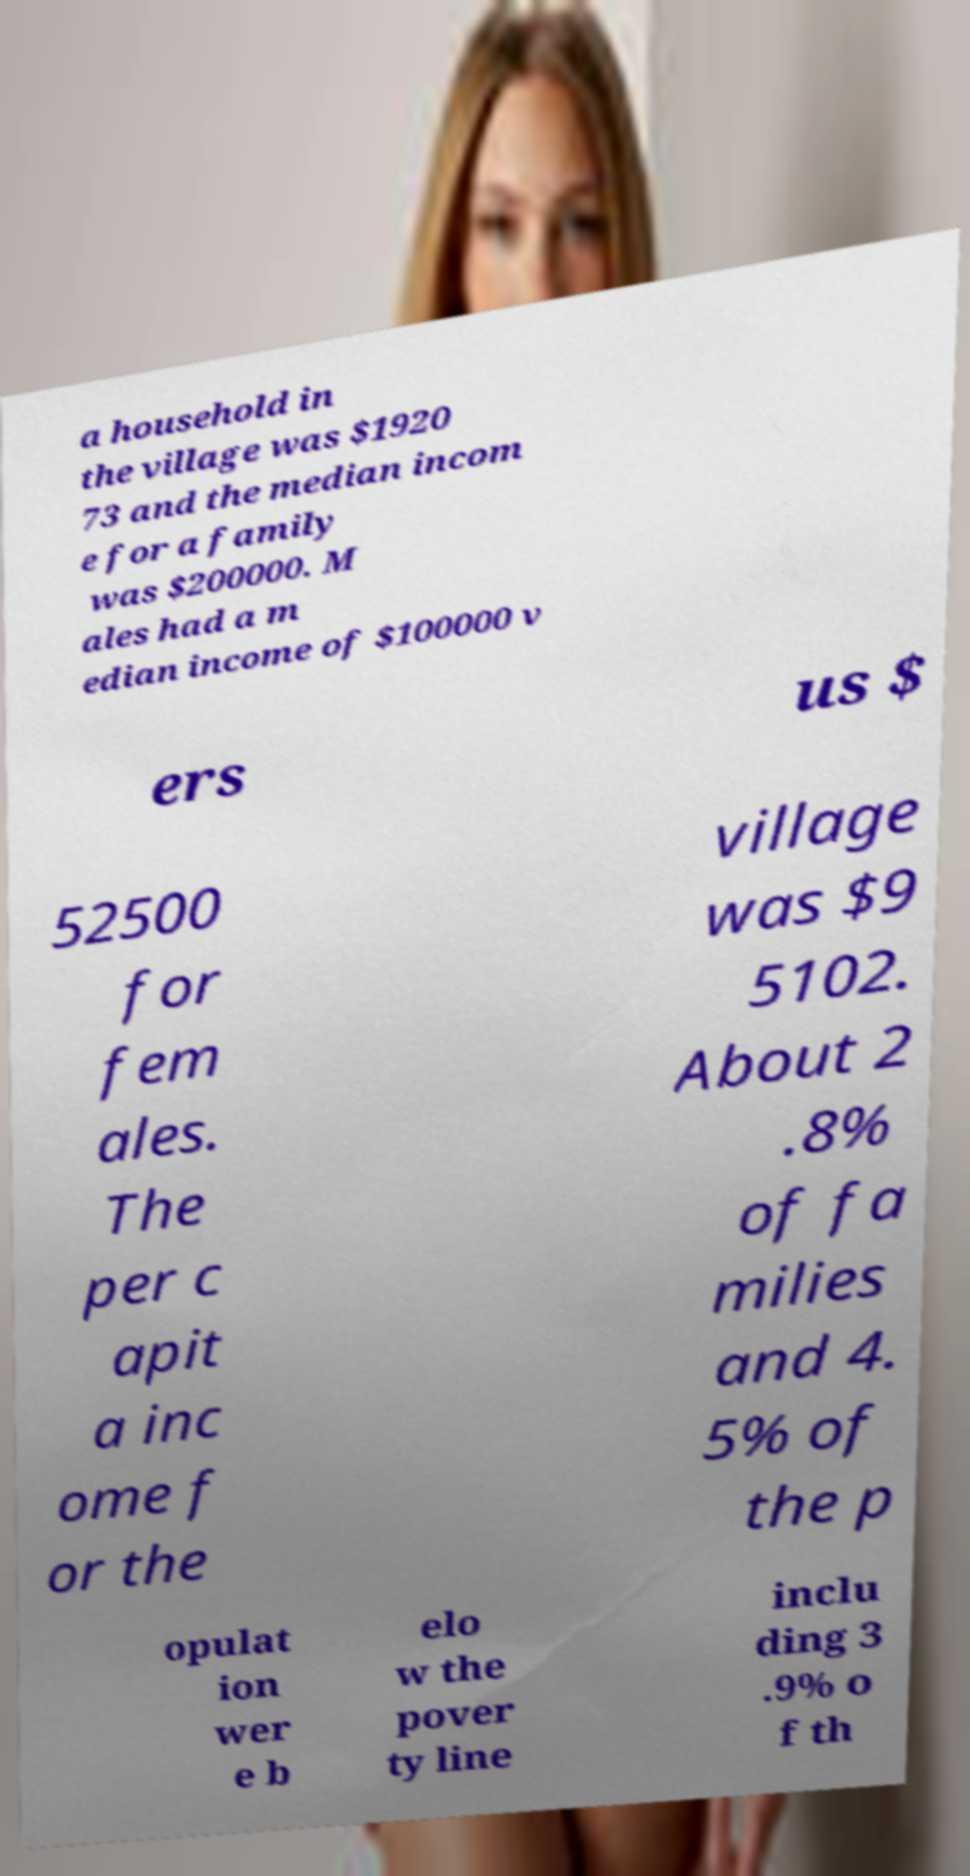Could you extract and type out the text from this image? a household in the village was $1920 73 and the median incom e for a family was $200000. M ales had a m edian income of $100000 v ers us $ 52500 for fem ales. The per c apit a inc ome f or the village was $9 5102. About 2 .8% of fa milies and 4. 5% of the p opulat ion wer e b elo w the pover ty line inclu ding 3 .9% o f th 